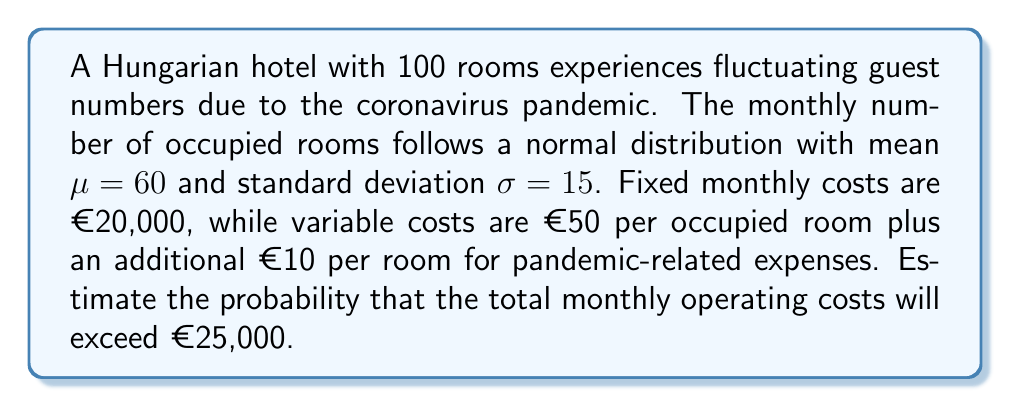What is the answer to this math problem? Let's approach this step-by-step:

1) First, we need to express the total monthly operating costs as a function of the number of occupied rooms, $X$:

   Total Cost = Fixed Cost + Variable Cost
   $C(X) = 20000 + 60X$

2) We want to find $P(C(X) > 25000)$

3) This is equivalent to finding $P(20000 + 60X > 25000)$
                               $P(60X > 5000)$
                               $P(X > \frac{5000}{60})$
                               $P(X > 83.33)$

4) We know that $X \sim N(60, 15^2)$

5) To standardize this, we calculate the z-score:

   $z = \frac{X - \mu}{\sigma} = \frac{83.33 - 60}{15} = 1.56$

6) Now we need to find $P(Z > 1.56)$, where $Z$ is the standard normal distribution

7) Using a standard normal table or calculator, we find:

   $P(Z > 1.56) = 1 - P(Z < 1.56) = 1 - 0.9406 = 0.0594$

Therefore, the probability that the total monthly operating costs will exceed €25,000 is approximately 0.0594 or 5.94%.
Answer: 0.0594 